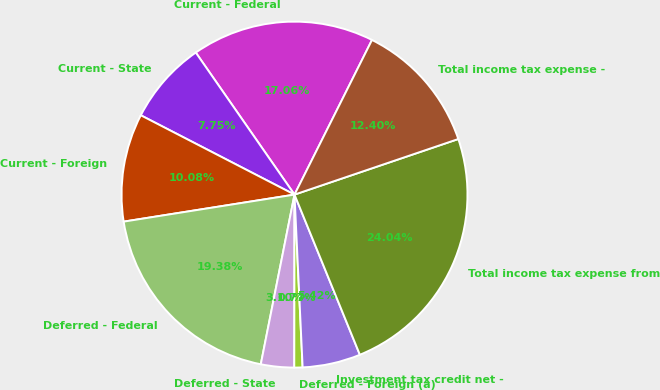Convert chart to OTSL. <chart><loc_0><loc_0><loc_500><loc_500><pie_chart><fcel>Current - Federal<fcel>Current - State<fcel>Current - Foreign<fcel>Deferred - Federal<fcel>Deferred - State<fcel>Deferred - Foreign (a)<fcel>Investment tax credit net -<fcel>Total income tax expense from<fcel>Total income tax expense -<nl><fcel>17.06%<fcel>7.75%<fcel>10.08%<fcel>19.38%<fcel>3.1%<fcel>0.77%<fcel>5.42%<fcel>24.04%<fcel>12.4%<nl></chart> 